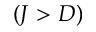Convert formula to latex. <formula><loc_0><loc_0><loc_500><loc_500>( J > D )</formula> 